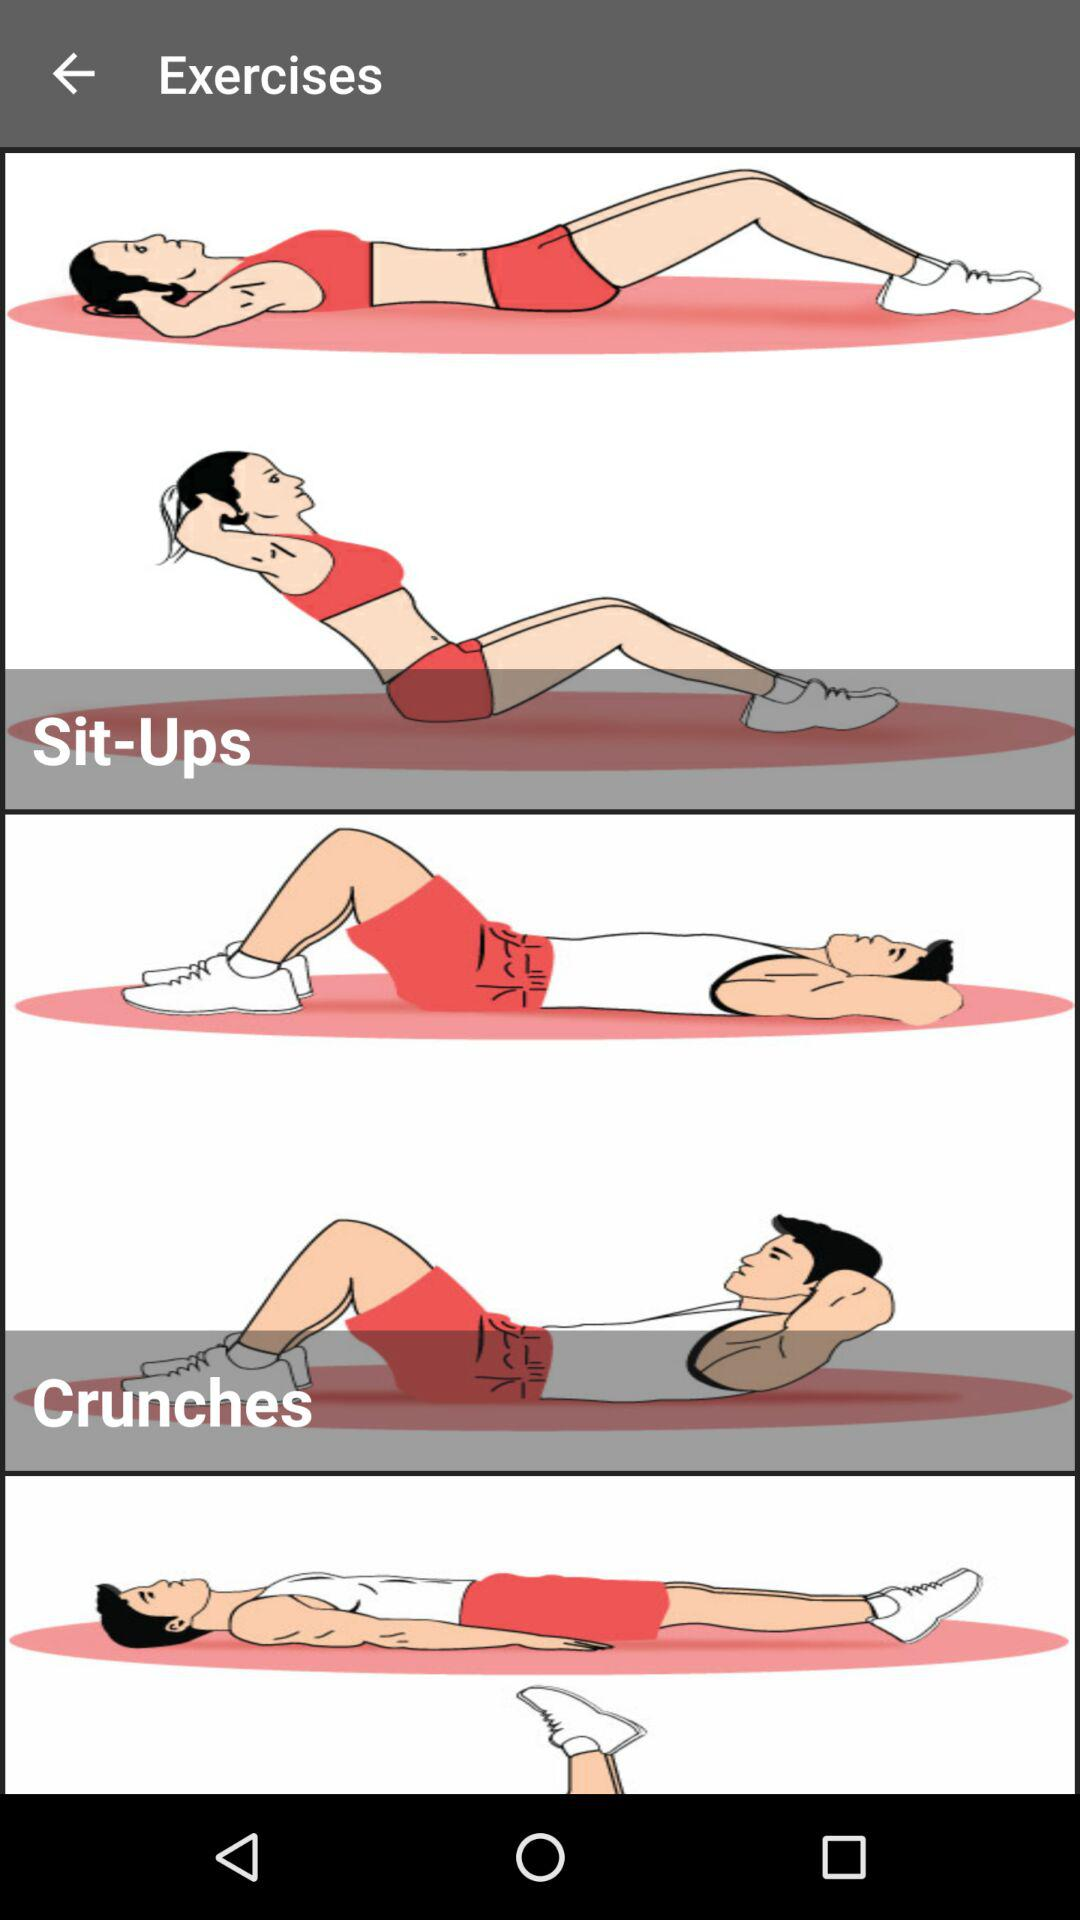How many exercises are shown before the last exercise?
Answer the question using a single word or phrase. 2 